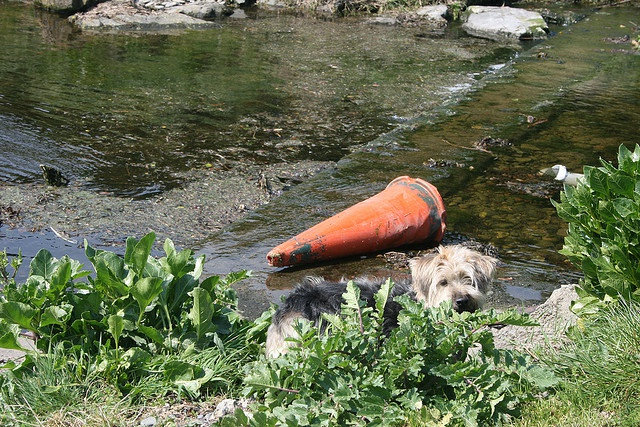Describe the objects in this image and their specific colors. I can see a dog in black, lightgray, gray, and darkgray tones in this image. 